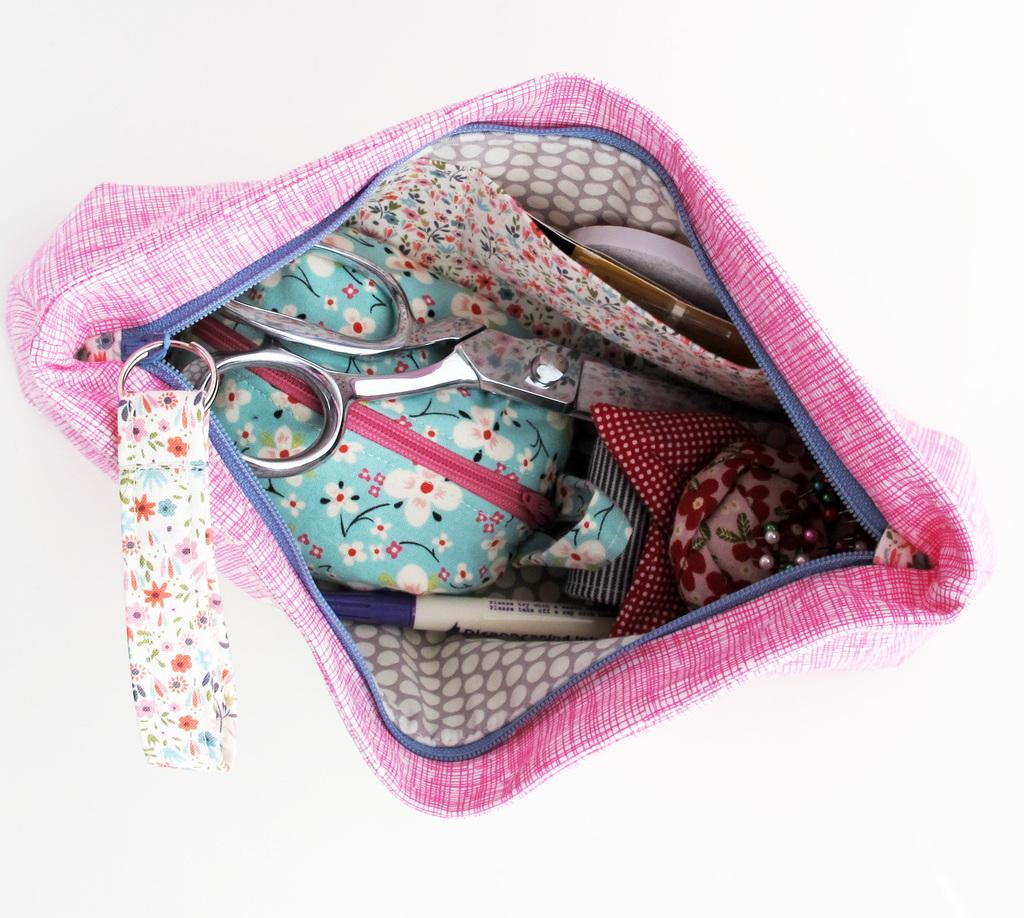What can be seen in the image? There is a bag in the image. Where is the bag located? The bag is placed on a surface. What items are inside the bag? There is a scissor, a pen, and a pouch inside the bag, along with other objects. Can you see any eggs being smashed on the spot in the image? There are no eggs or any smashing activity present in the image. 